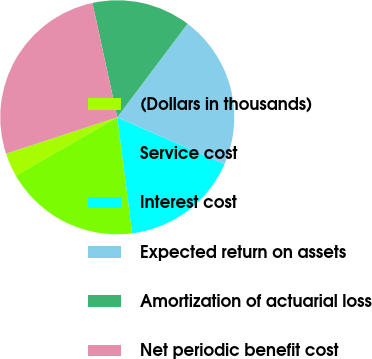Convert chart. <chart><loc_0><loc_0><loc_500><loc_500><pie_chart><fcel>(Dollars in thousands)<fcel>Service cost<fcel>Interest cost<fcel>Expected return on assets<fcel>Amortization of actuarial loss<fcel>Net periodic benefit cost<nl><fcel>3.29%<fcel>18.72%<fcel>16.39%<fcel>21.31%<fcel>13.66%<fcel>26.62%<nl></chart> 